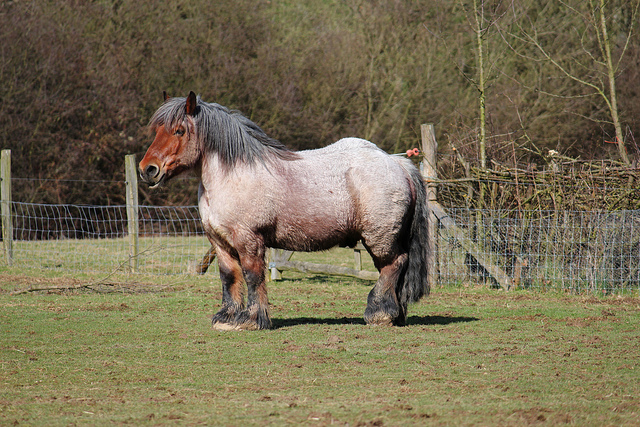<image>What species of Zebra are in the photo? It is not possible to identify the species of Zebra in the photo as there is no Zebra visible. What species of Zebra are in the photo? I don't know the species of Zebra in the photo. It is not possible to determine from the given options. 